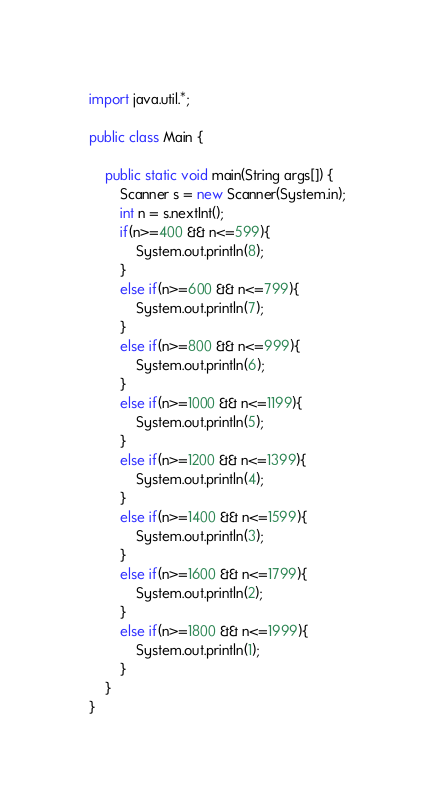Convert code to text. <code><loc_0><loc_0><loc_500><loc_500><_Java_>import java.util.*;

public class Main {

    public static void main(String args[]) {
        Scanner s = new Scanner(System.in);
        int n = s.nextInt();
        if(n>=400 && n<=599){
            System.out.println(8);
        }
        else if(n>=600 && n<=799){
            System.out.println(7);
        }
        else if(n>=800 && n<=999){
            System.out.println(6);
        }
        else if(n>=1000 && n<=1199){
            System.out.println(5);
        }
        else if(n>=1200 && n<=1399){
            System.out.println(4);
        }
        else if(n>=1400 && n<=1599){
            System.out.println(3);
        }
        else if(n>=1600 && n<=1799){
            System.out.println(2);
        }
        else if(n>=1800 && n<=1999){
            System.out.println(1);
        }
    }
}

</code> 